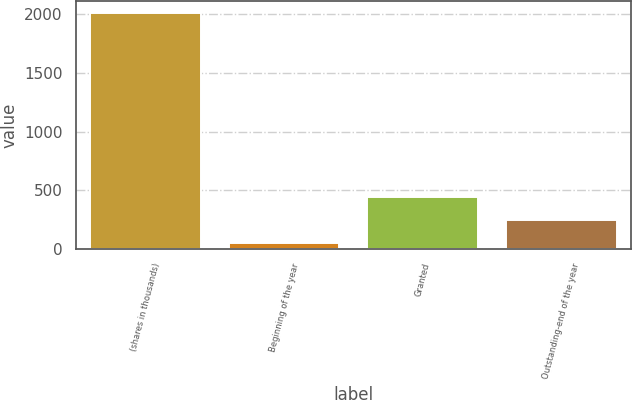<chart> <loc_0><loc_0><loc_500><loc_500><bar_chart><fcel>(shares in thousands)<fcel>Beginning of the year<fcel>Granted<fcel>Outstanding-end of the year<nl><fcel>2014<fcel>51.73<fcel>444.19<fcel>247.96<nl></chart> 